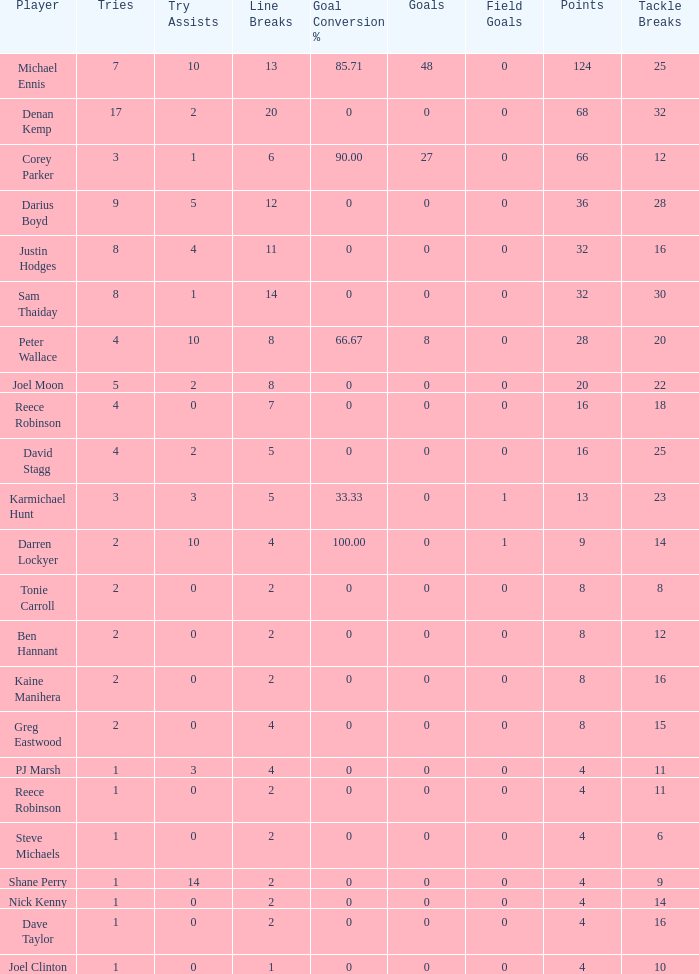How many goals did the player with less than 4 points have? 0.0. 